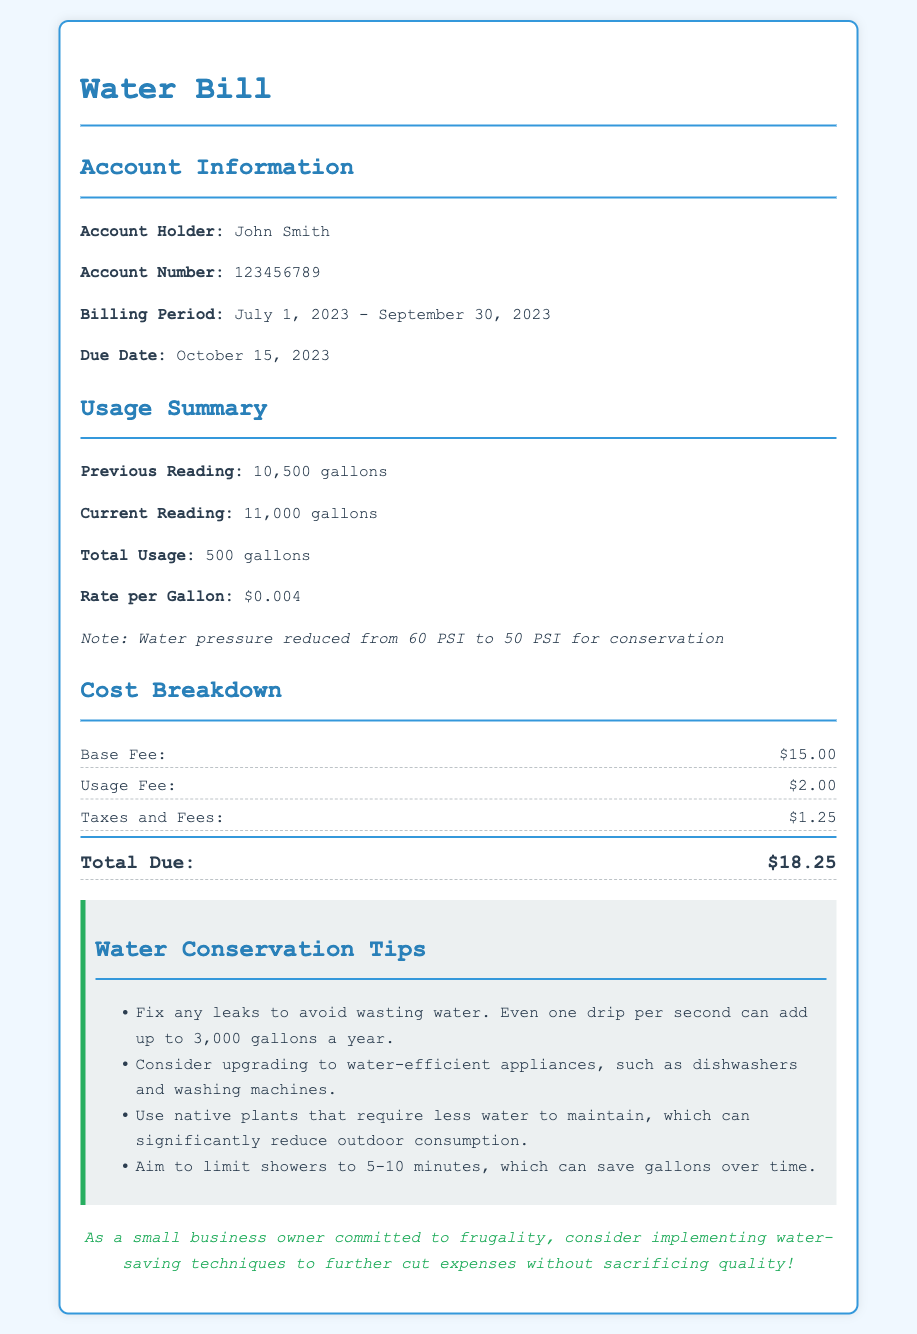What is the account holder's name? The account holder's name is provided in the Account Information section of the document.
Answer: John Smith What is the total usage of water this quarter? The total usage is mentioned in the Usage Summary section and is calculated from the previous and current reading.
Answer: 500 gallons What is the rate per gallon of water? The rate per gallon is specified in the Usage Summary section.
Answer: $0.004 What is the due date for the water bill? The due date is mentioned in the Account Information section.
Answer: October 15, 2023 What is the total amount due on the bill? The total amount due is found in the Cost Breakdown section.
Answer: $18.25 How much is the base fee? The base fee is listed in the Cost Breakdown section.
Answer: $15.00 What conservation measure was taken regarding water pressure? The conservation measure regarding water pressure is noted in the Usage Summary section.
Answer: Reduced from 60 PSI to 50 PSI What is one of the tips for conserving water? One of the tips for conserving water is provided in the Water Conservation Tips section.
Answer: Fix any leaks How can limiting shower time help in saving water? The reasoning behind limiting shower time is mentioned in the Water Conservation Tips section as a method to save gallons.
Answer: It can save gallons over time What is suggested to reduce outdoor water consumption? The document recommends using specific types of plants to minimize outdoor water usage.
Answer: Native plants 